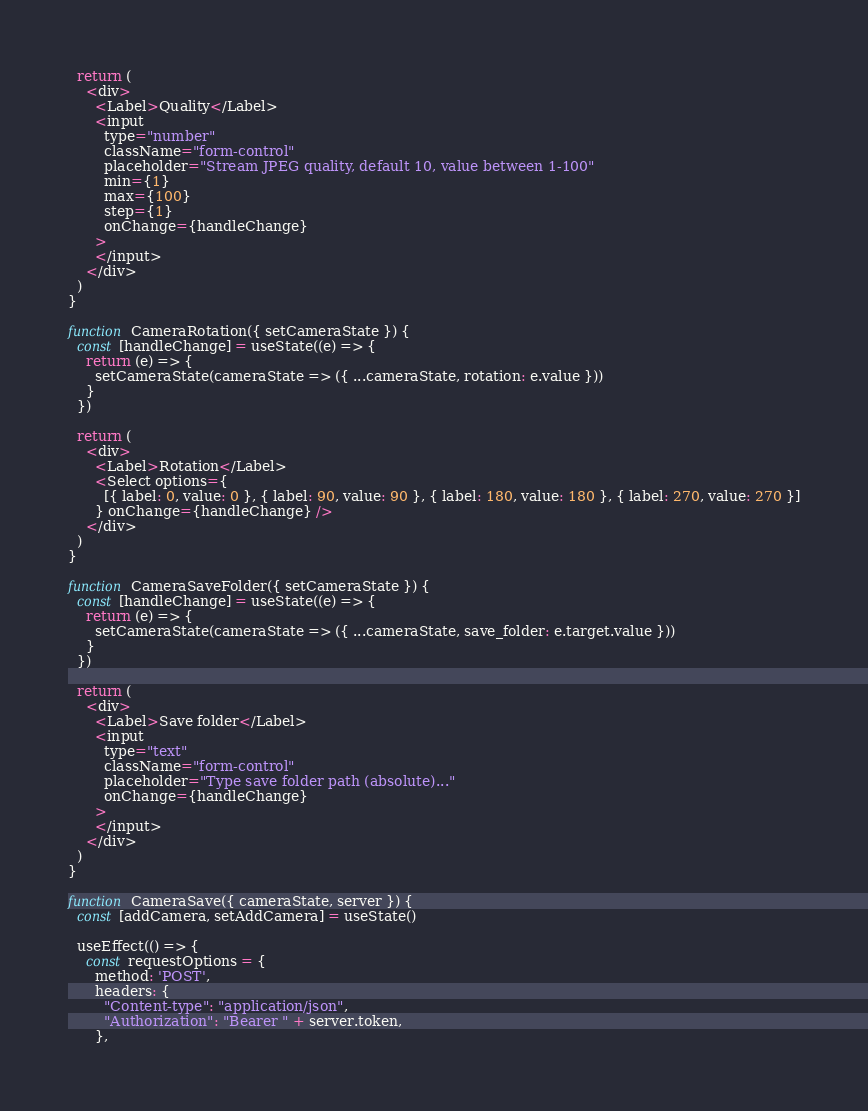<code> <loc_0><loc_0><loc_500><loc_500><_JavaScript_>
  return (
    <div>
      <Label>Quality</Label>
      <input
        type="number"
        className="form-control"
        placeholder="Stream JPEG quality, default 10, value between 1-100"
        min={1}
        max={100}
        step={1}
        onChange={handleChange}
      >
      </input>
    </div>
  )
}

function CameraRotation({ setCameraState }) {
  const [handleChange] = useState((e) => {
    return (e) => {
      setCameraState(cameraState => ({ ...cameraState, rotation: e.value }))
    }
  })

  return (
    <div>
      <Label>Rotation</Label>
      <Select options={
        [{ label: 0, value: 0 }, { label: 90, value: 90 }, { label: 180, value: 180 }, { label: 270, value: 270 }]
      } onChange={handleChange} />
    </div>
  )
}

function CameraSaveFolder({ setCameraState }) {
  const [handleChange] = useState((e) => {
    return (e) => {
      setCameraState(cameraState => ({ ...cameraState, save_folder: e.target.value }))
    }
  })

  return (
    <div>
      <Label>Save folder</Label>
      <input
        type="text"
        className="form-control"
        placeholder="Type save folder path (absolute)..."
        onChange={handleChange}
      >
      </input>
    </div>
  )
}

function CameraSave({ cameraState, server }) {
  const [addCamera, setAddCamera] = useState()

  useEffect(() => {
    const requestOptions = {
      method: 'POST',
      headers: {
        "Content-type": "application/json",
        "Authorization": "Bearer " + server.token,
      },</code> 